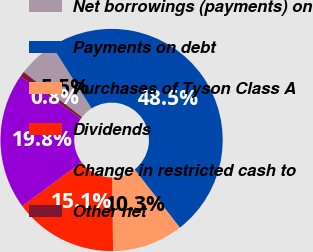Convert chart. <chart><loc_0><loc_0><loc_500><loc_500><pie_chart><fcel>Net borrowings (payments) on<fcel>Payments on debt<fcel>Purchases of Tyson Class A<fcel>Dividends<fcel>Change in restricted cash to<fcel>Other net<nl><fcel>5.54%<fcel>48.47%<fcel>10.31%<fcel>15.08%<fcel>19.85%<fcel>0.77%<nl></chart> 